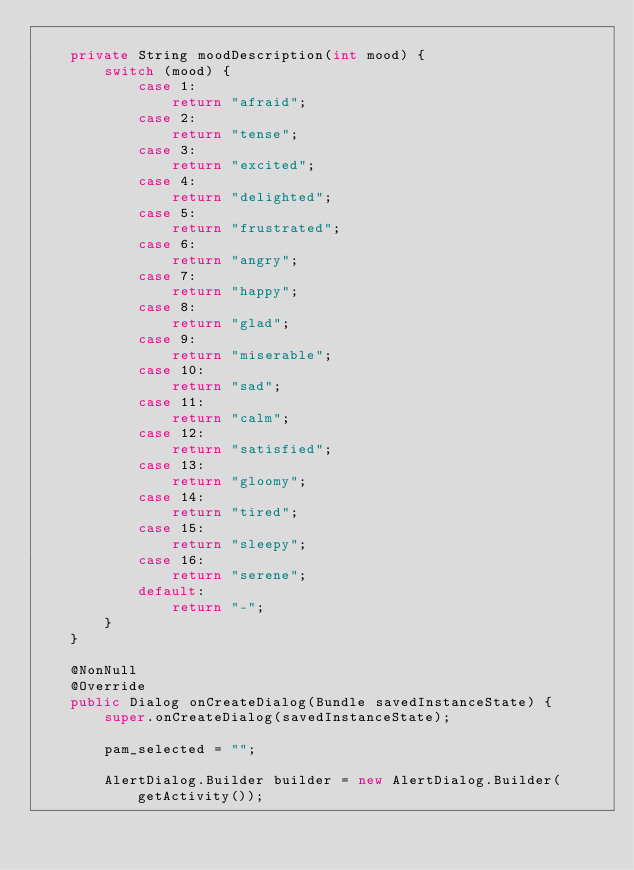Convert code to text. <code><loc_0><loc_0><loc_500><loc_500><_Java_>
    private String moodDescription(int mood) {
        switch (mood) {
            case 1:
                return "afraid";
            case 2:
                return "tense";
            case 3:
                return "excited";
            case 4:
                return "delighted";
            case 5:
                return "frustrated";
            case 6:
                return "angry";
            case 7:
                return "happy";
            case 8:
                return "glad";
            case 9:
                return "miserable";
            case 10:
                return "sad";
            case 11:
                return "calm";
            case 12:
                return "satisfied";
            case 13:
                return "gloomy";
            case 14:
                return "tired";
            case 15:
                return "sleepy";
            case 16:
                return "serene";
            default:
                return "-";
        }
    }

    @NonNull
    @Override
    public Dialog onCreateDialog(Bundle savedInstanceState) {
        super.onCreateDialog(savedInstanceState);

        pam_selected = "";

        AlertDialog.Builder builder = new AlertDialog.Builder(getActivity());</code> 